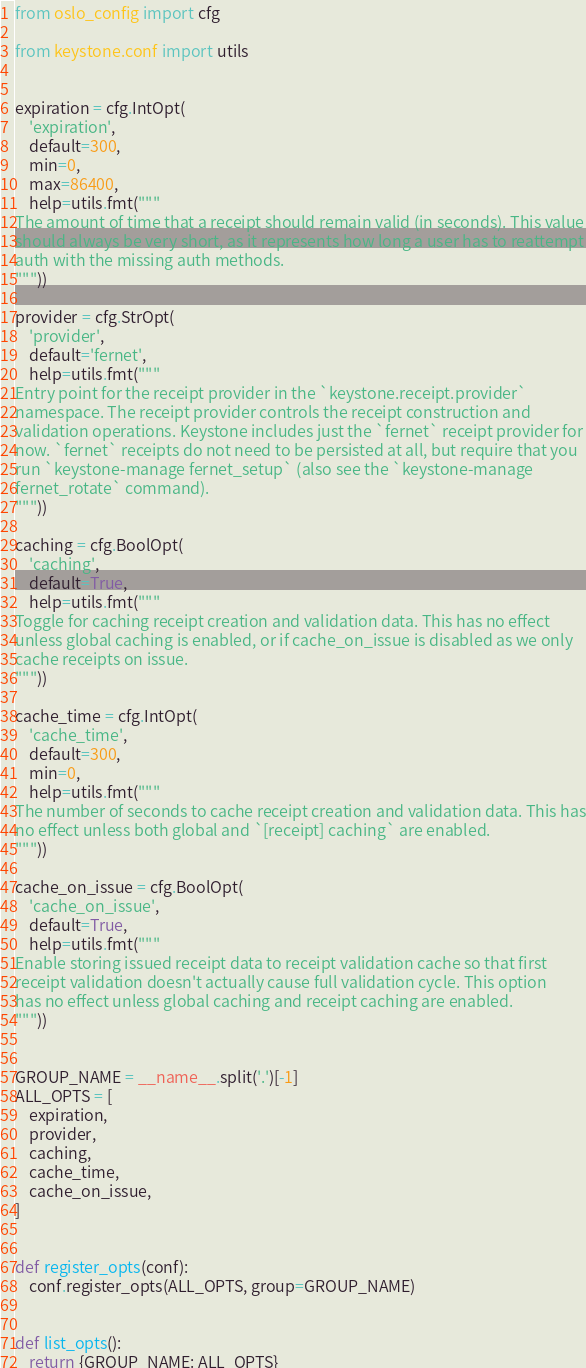Convert code to text. <code><loc_0><loc_0><loc_500><loc_500><_Python_>from oslo_config import cfg

from keystone.conf import utils


expiration = cfg.IntOpt(
    'expiration',
    default=300,
    min=0,
    max=86400,
    help=utils.fmt("""
The amount of time that a receipt should remain valid (in seconds). This value
should always be very short, as it represents how long a user has to reattempt
auth with the missing auth methods.
"""))

provider = cfg.StrOpt(
    'provider',
    default='fernet',
    help=utils.fmt("""
Entry point for the receipt provider in the `keystone.receipt.provider`
namespace. The receipt provider controls the receipt construction and
validation operations. Keystone includes just the `fernet` receipt provider for
now. `fernet` receipts do not need to be persisted at all, but require that you
run `keystone-manage fernet_setup` (also see the `keystone-manage
fernet_rotate` command).
"""))

caching = cfg.BoolOpt(
    'caching',
    default=True,
    help=utils.fmt("""
Toggle for caching receipt creation and validation data. This has no effect
unless global caching is enabled, or if cache_on_issue is disabled as we only
cache receipts on issue.
"""))

cache_time = cfg.IntOpt(
    'cache_time',
    default=300,
    min=0,
    help=utils.fmt("""
The number of seconds to cache receipt creation and validation data. This has
no effect unless both global and `[receipt] caching` are enabled.
"""))

cache_on_issue = cfg.BoolOpt(
    'cache_on_issue',
    default=True,
    help=utils.fmt("""
Enable storing issued receipt data to receipt validation cache so that first
receipt validation doesn't actually cause full validation cycle. This option
has no effect unless global caching and receipt caching are enabled.
"""))


GROUP_NAME = __name__.split('.')[-1]
ALL_OPTS = [
    expiration,
    provider,
    caching,
    cache_time,
    cache_on_issue,
]


def register_opts(conf):
    conf.register_opts(ALL_OPTS, group=GROUP_NAME)


def list_opts():
    return {GROUP_NAME: ALL_OPTS}
</code> 